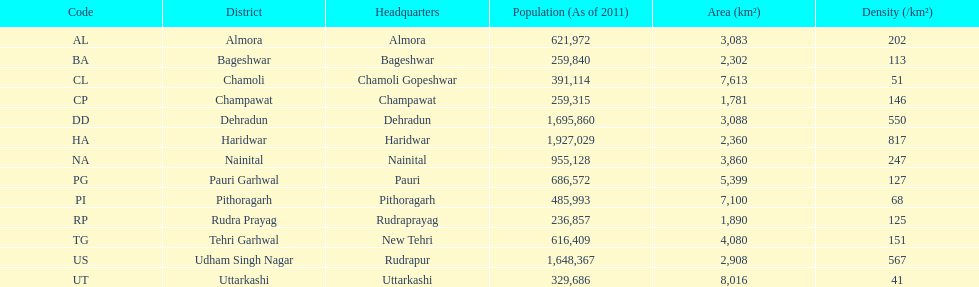What is the aggregate sum of districts listed? 13. 